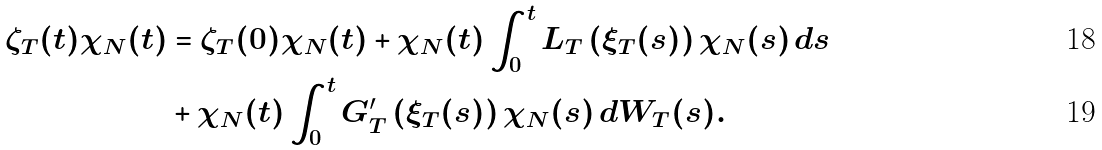Convert formula to latex. <formula><loc_0><loc_0><loc_500><loc_500>\zeta _ { T } ( t ) \chi _ { N } ( t ) & = \zeta _ { T } ( 0 ) \chi _ { N } ( t ) + \chi _ { N } ( t ) \int _ { 0 } ^ { t } L _ { T } \left ( \xi _ { T } ( s ) \right ) \chi _ { N } ( s ) \, d s \\ & + \chi _ { N } ( t ) \int _ { 0 } ^ { t } G _ { T } ^ { \prime } \left ( \xi _ { T } ( s ) \right ) \chi _ { N } ( s ) \, d W _ { T } ( s ) .</formula> 